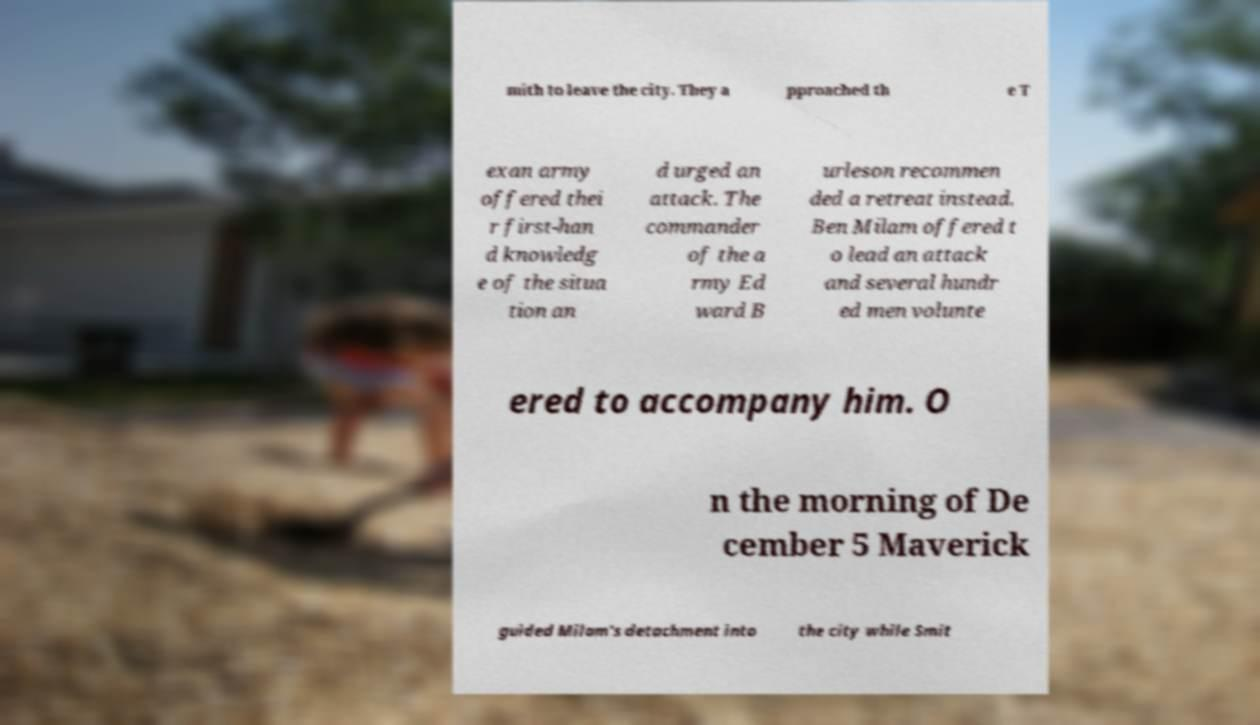Please read and relay the text visible in this image. What does it say? mith to leave the city. They a pproached th e T exan army offered thei r first-han d knowledg e of the situa tion an d urged an attack. The commander of the a rmy Ed ward B urleson recommen ded a retreat instead. Ben Milam offered t o lead an attack and several hundr ed men volunte ered to accompany him. O n the morning of De cember 5 Maverick guided Milam's detachment into the city while Smit 